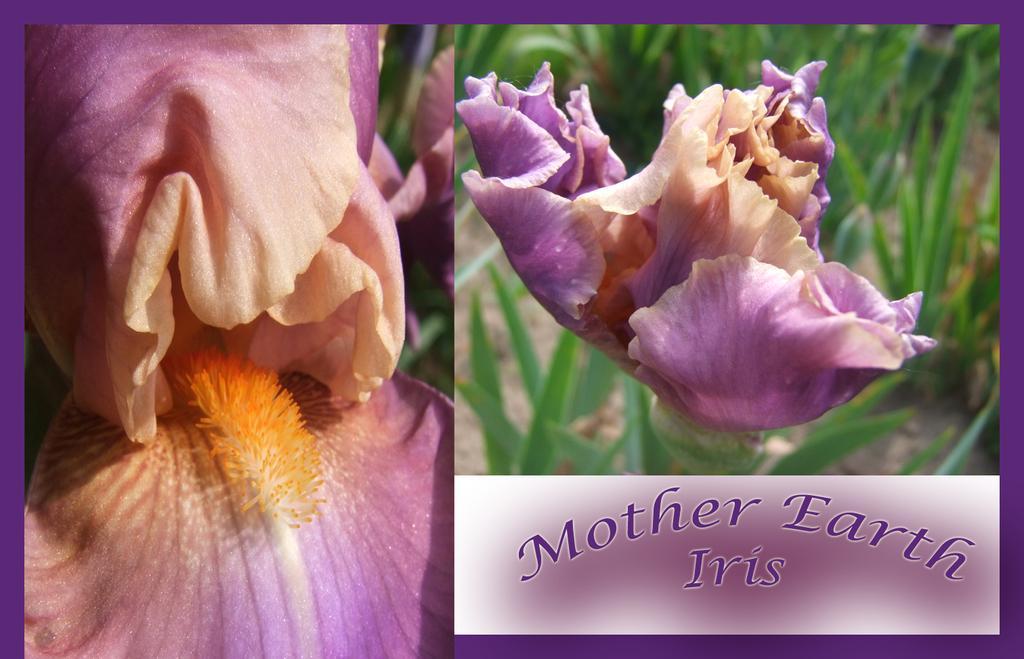Could you give a brief overview of what you see in this image? In this image, we can see flowers. 